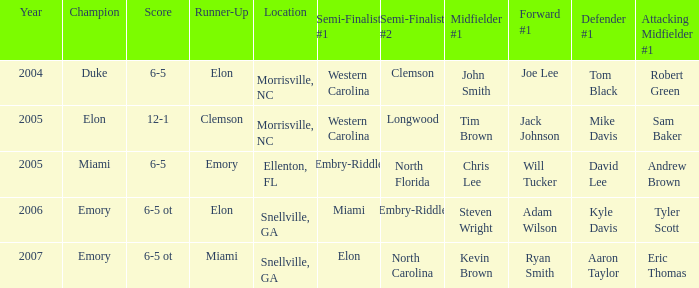Which team was the second semi finalist in 2007? North Carolina. 